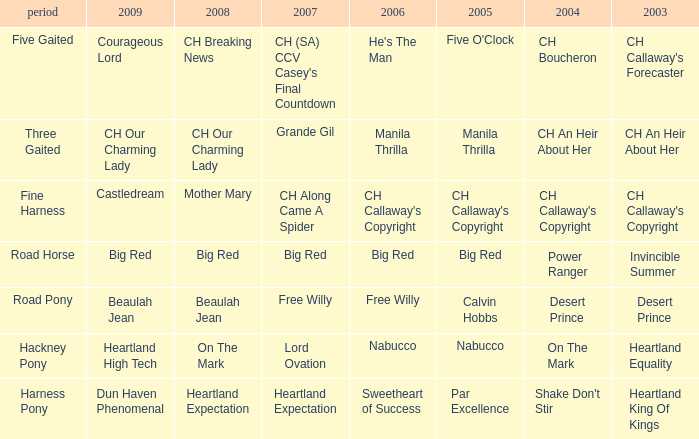What is the 2008 for the 2009 ch our charming lady? CH Our Charming Lady. 